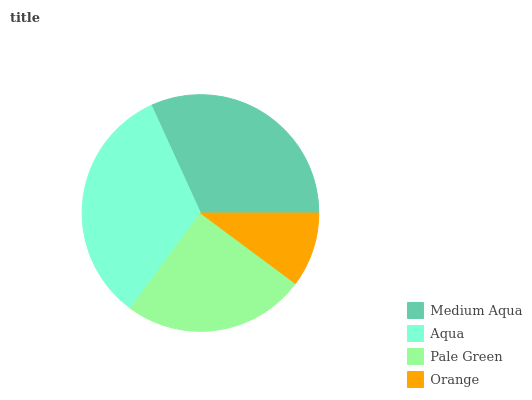Is Orange the minimum?
Answer yes or no. Yes. Is Aqua the maximum?
Answer yes or no. Yes. Is Pale Green the minimum?
Answer yes or no. No. Is Pale Green the maximum?
Answer yes or no. No. Is Aqua greater than Pale Green?
Answer yes or no. Yes. Is Pale Green less than Aqua?
Answer yes or no. Yes. Is Pale Green greater than Aqua?
Answer yes or no. No. Is Aqua less than Pale Green?
Answer yes or no. No. Is Medium Aqua the high median?
Answer yes or no. Yes. Is Pale Green the low median?
Answer yes or no. Yes. Is Aqua the high median?
Answer yes or no. No. Is Medium Aqua the low median?
Answer yes or no. No. 